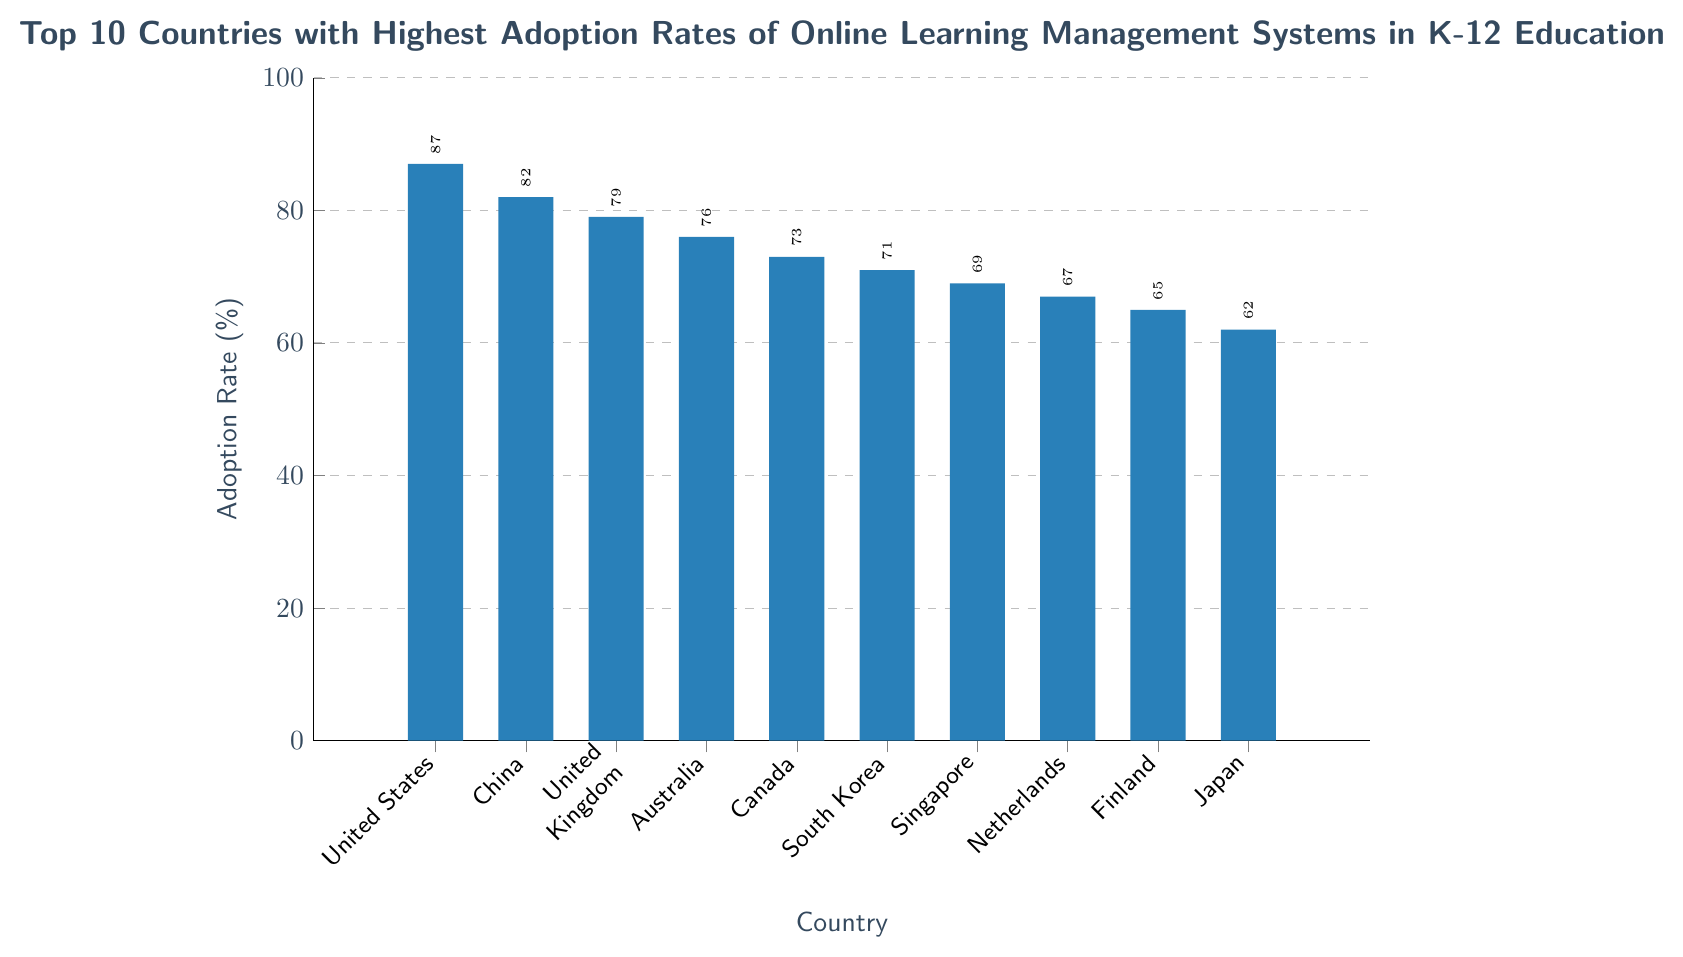Which country has the highest adoption rate of online learning management systems in K-12 education? The bar representing the United States is the tallest in the chart, which indicates it has the highest adoption rate.
Answer: United States Which two countries have equal height bars, suggesting similar adoption rates? The bars for South Korea and Singapore are of equal height, indicating that both countries have similar adoption rates.
Answer: South Korea and Singapore How much higher is the adoption rate in the United States compared to Japan? The adoption rate for the United States is 87%, and for Japan, it is 62%. The difference is calculated as 87% - 62% = 25%.
Answer: 25% Among the top 5 countries, which one has the lowest adoption rate? In the top 5 countries, United States, China, United Kingdom, Australia, and Canada are listed. Canada has the lowest adoption rate at 73%.
Answer: Canada What is the sum of the adoption rates for the United Kingdom and Australia? The adoption rates for the United Kingdom and Australia are 79% and 76% respectively. The sum is 79% + 76% = 155%.
Answer: 155% Which country ranks 4th in terms of adoption rate, and what is this rate? Australia is the 4th country when listed by descending adoption rates, with an adoption rate of 76%.
Answer: Australia, 76% Order the top 5 countries by adoption rate in descending order. The top 5 countries in descending order of adoption rates are: United States (87%), China (82%), United Kingdom (79%), Australia (76%), and Canada (73%).
Answer: United States, China, United Kingdom, Australia, Canada What is the average adoption rate of online learning management systems for the top 10 countries listed? The adoption rates are: 87, 82, 79, 76, 73, 71, 69, 67, 65, 62. Summing these gives 731. Dividing by the number of countries (10) gives an average of 73.1%.
Answer: 73.1% Which country has the smallest adoption rate and what percentage does it represent? Japan has the smallest adoption rate in this chart, which is 62%.
Answer: Japan, 62% Compare Canada's and the Netherlands' adoption rates. Which is higher? The adoption rate for Canada is 73% and for the Netherlands, it is 67%. Therefore, Canada's adoption rate is higher.
Answer: Canada 